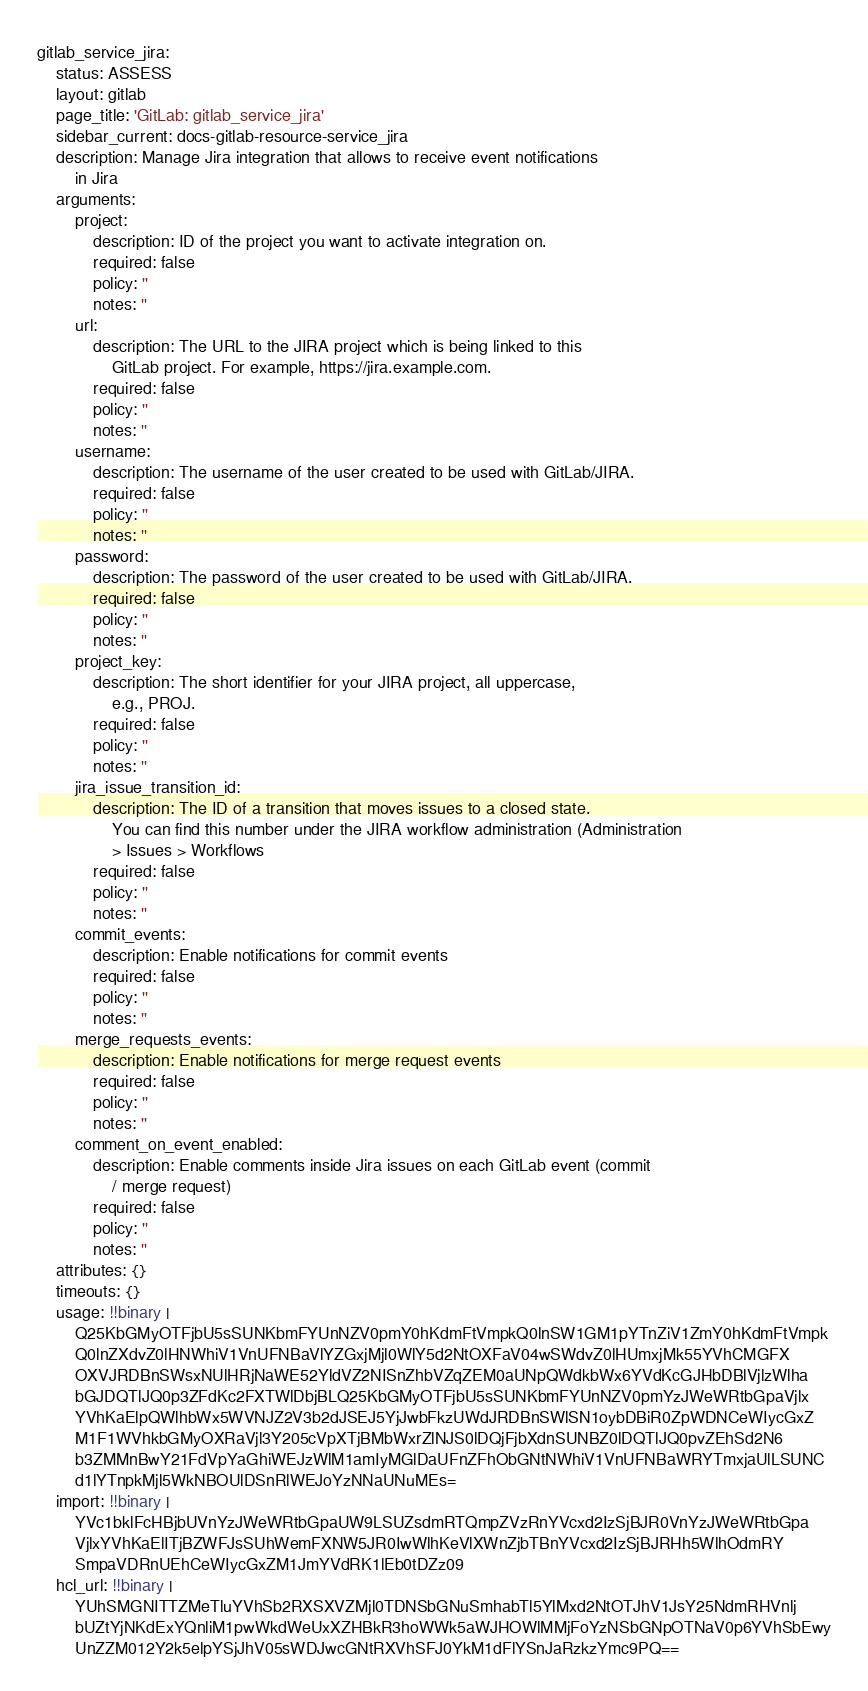<code> <loc_0><loc_0><loc_500><loc_500><_YAML_>gitlab_service_jira:
    status: ASSESS
    layout: gitlab
    page_title: 'GitLab: gitlab_service_jira'
    sidebar_current: docs-gitlab-resource-service_jira
    description: Manage Jira integration that allows to receive event notifications
        in Jira
    arguments:
        project:
            description: ID of the project you want to activate integration on.
            required: false
            policy: ''
            notes: ''
        url:
            description: The URL to the JIRA project which is being linked to this
                GitLab project. For example, https://jira.example.com.
            required: false
            policy: ''
            notes: ''
        username:
            description: The username of the user created to be used with GitLab/JIRA.
            required: false
            policy: ''
            notes: ''
        password:
            description: The password of the user created to be used with GitLab/JIRA.
            required: false
            policy: ''
            notes: ''
        project_key:
            description: The short identifier for your JIRA project, all uppercase,
                e.g., PROJ.
            required: false
            policy: ''
            notes: ''
        jira_issue_transition_id:
            description: The ID of a transition that moves issues to a closed state.
                You can find this number under the JIRA workflow administration (Administration
                > Issues > Workflows
            required: false
            policy: ''
            notes: ''
        commit_events:
            description: Enable notifications for commit events
            required: false
            policy: ''
            notes: ''
        merge_requests_events:
            description: Enable notifications for merge request events
            required: false
            policy: ''
            notes: ''
        comment_on_event_enabled:
            description: Enable comments inside Jira issues on each GitLab event (commit
                / merge request)
            required: false
            policy: ''
            notes: ''
    attributes: {}
    timeouts: {}
    usage: !!binary |
        Q25KbGMyOTFjbU5sSUNKbmFYUnNZV0pmY0hKdmFtVmpkQ0lnSW1GM1pYTnZiV1ZmY0hKdmFtVmpk
        Q0lnZXdvZ0lHNWhiV1VnUFNBaVlYZGxjMjl0WlY5d2NtOXFaV04wSWdvZ0lHUmxjMk55YVhCMGFX
        OXVJRDBnSWsxNUlHRjNaWE52YldVZ2NISnZhbVZqZEM0aUNpQWdkbWx6YVdKcGJHbDBlVjlzWlha
        bGJDQTlJQ0p3ZFdKc2FXTWlDbjBLQ25KbGMyOTFjbU5sSUNKbmFYUnNZV0pmYzJWeWRtbGpaVjlx
        YVhKaElpQWlhbWx5WVNJZ2V3b2dJSEJ5YjJwbFkzUWdJRDBnSWlSN1oybDBiR0ZpWDNCeWIycGxZ
        M1F1WVhkbGMyOXRaVjl3Y205cVpXTjBMbWxrZlNJS0lDQjFjbXdnSUNBZ0lDQTlJQ0pvZEhSd2N6
        b3ZMMnBwY21FdVpYaGhiWEJzWlM1amIyMGlDaUFnZFhObGNtNWhiV1VnUFNBaWRYTmxjaUlLSUNC
        d1lYTnpkMjl5WkNBOUlDSnRlWEJoYzNNaUNuMEs=
    import: !!binary |
        YVc1bklFcHBjbUVnYzJWeWRtbGpaUW9LSUZsdmRTQmpZVzRnYVcxd2IzSjBJR0VnYzJWeWRtbGpa
        VjlxYVhKaElITjBZWFJsSUhWemFXNW5JR0IwWlhKeVlXWnZjbTBnYVcxd2IzSjBJRHh5WlhOdmRY
        SmpaVDRnUEhCeWIycGxZM1JmYVdRK1lEb0tDZz09
    hcl_url: !!binary |
        YUhSMGNITTZMeTluYVhSb2RXSXVZMjl0TDNSbGNuSmhabTl5YlMxd2NtOTJhV1JsY25NdmRHVnlj
        bUZtYjNKdExYQnliM1pwWkdWeUxXZHBkR3hoWWk5aWJHOWlMMjFoYzNSbGNpOTNaV0p6YVhSbEwy
        UnZZM012Y2k5elpYSjJhV05sWDJwcGNtRXVhSFJ0YkM1dFlYSnJaRzkzYmc9PQ==
</code> 